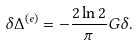<formula> <loc_0><loc_0><loc_500><loc_500>\delta \Delta ^ { ( e ) } = - \frac { 2 \ln 2 } \pi G \delta .</formula> 